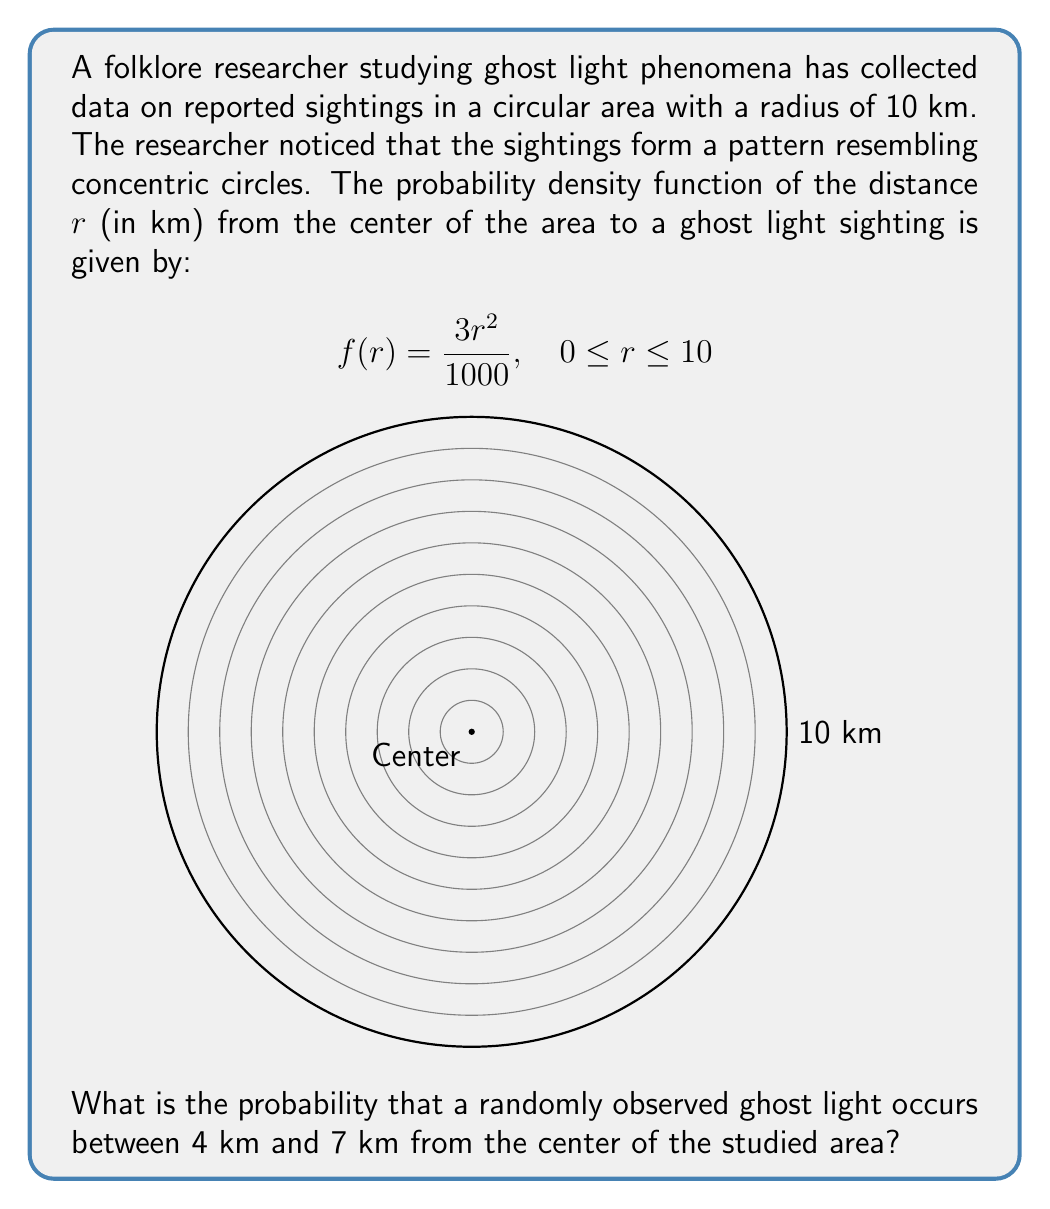What is the answer to this math problem? To solve this problem, we need to integrate the probability density function between 4 km and 7 km. Here's the step-by-step solution:

1) The probability is given by the integral of $f(r)$ from 4 to 7:

   $$P(4 \leq r \leq 7) = \int_4^7 f(r) dr = \int_4^7 \frac{3r^2}{1000} dr$$

2) Integrate the function:

   $$\int_4^7 \frac{3r^2}{1000} dr = \frac{3}{1000} \int_4^7 r^2 dr = \frac{3}{1000} \left[\frac{r^3}{3}\right]_4^7$$

3) Evaluate the integral:

   $$\frac{3}{1000} \left[\frac{7^3}{3} - \frac{4^3}{3}\right] = \frac{1}{1000} (343 - 64) = \frac{279}{1000}$$

4) Simplify the fraction:

   $$\frac{279}{1000} = 0.279$$

Therefore, the probability that a randomly observed ghost light occurs between 4 km and 7 km from the center is 0.279 or 27.9%.
Answer: 0.279 